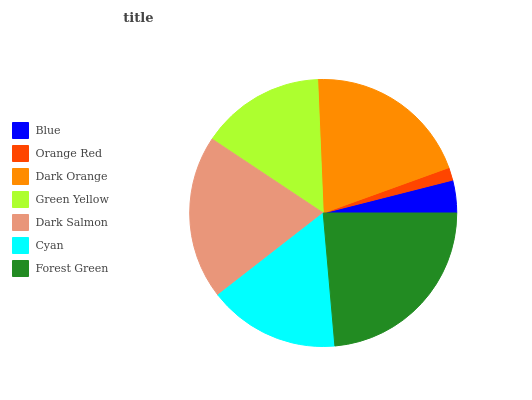Is Orange Red the minimum?
Answer yes or no. Yes. Is Forest Green the maximum?
Answer yes or no. Yes. Is Dark Orange the minimum?
Answer yes or no. No. Is Dark Orange the maximum?
Answer yes or no. No. Is Dark Orange greater than Orange Red?
Answer yes or no. Yes. Is Orange Red less than Dark Orange?
Answer yes or no. Yes. Is Orange Red greater than Dark Orange?
Answer yes or no. No. Is Dark Orange less than Orange Red?
Answer yes or no. No. Is Cyan the high median?
Answer yes or no. Yes. Is Cyan the low median?
Answer yes or no. Yes. Is Dark Orange the high median?
Answer yes or no. No. Is Forest Green the low median?
Answer yes or no. No. 